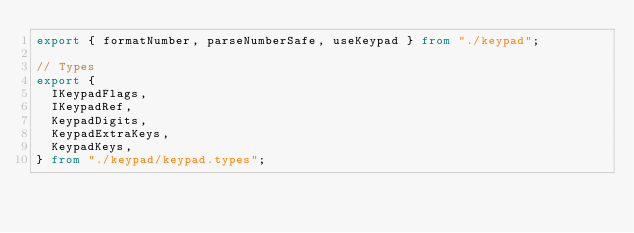Convert code to text. <code><loc_0><loc_0><loc_500><loc_500><_TypeScript_>export { formatNumber, parseNumberSafe, useKeypad } from "./keypad";

// Types
export {
  IKeypadFlags,
  IKeypadRef,
  KeypadDigits,
  KeypadExtraKeys,
  KeypadKeys,
} from "./keypad/keypad.types";
</code> 